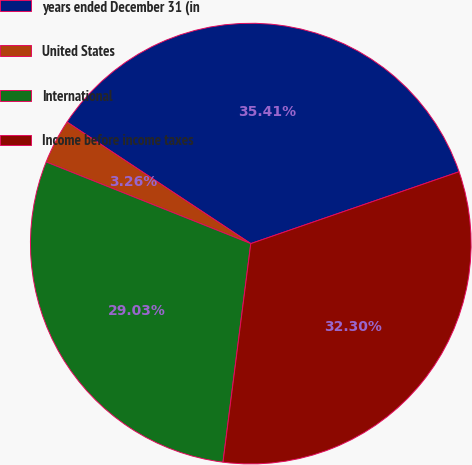Convert chart. <chart><loc_0><loc_0><loc_500><loc_500><pie_chart><fcel>years ended December 31 (in<fcel>United States<fcel>International<fcel>Income before income taxes<nl><fcel>35.41%<fcel>3.26%<fcel>29.03%<fcel>32.3%<nl></chart> 